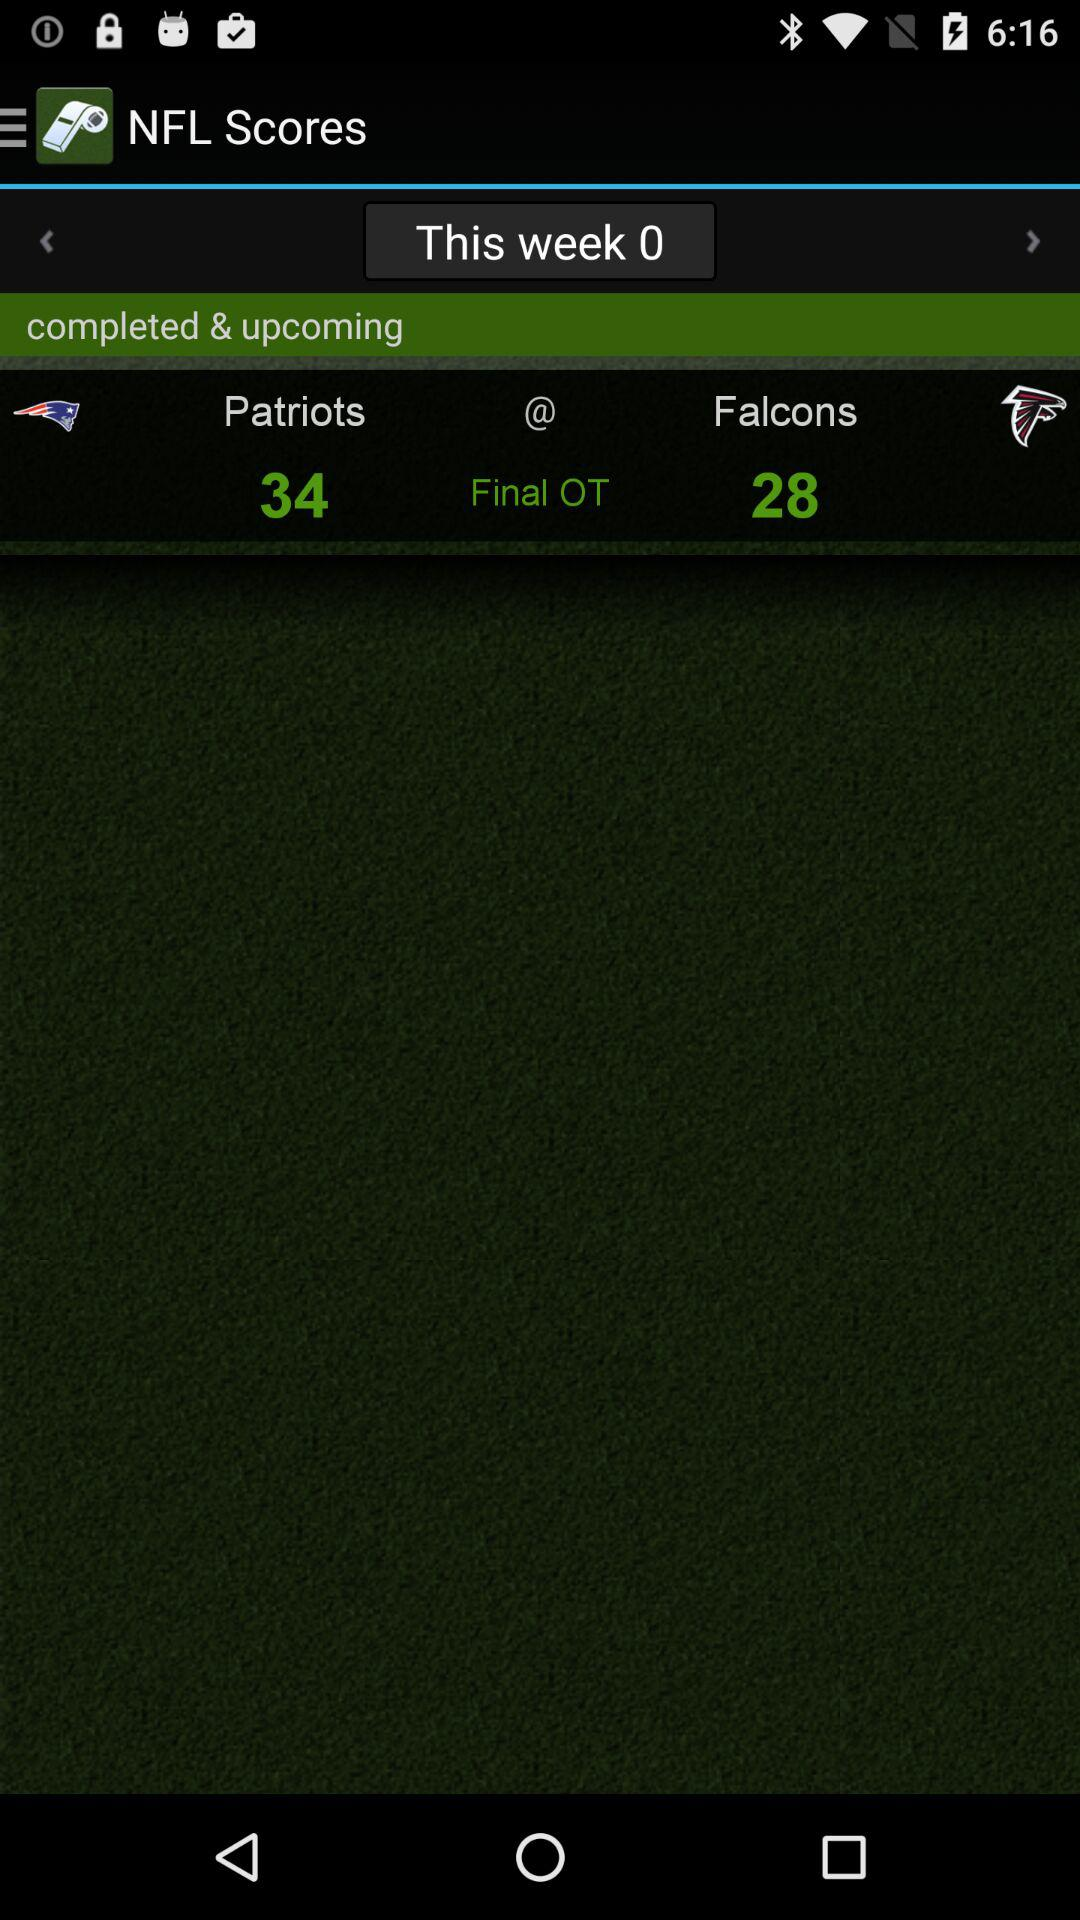How many points more did the Patriots score than the Falcons?
Answer the question using a single word or phrase. 6 